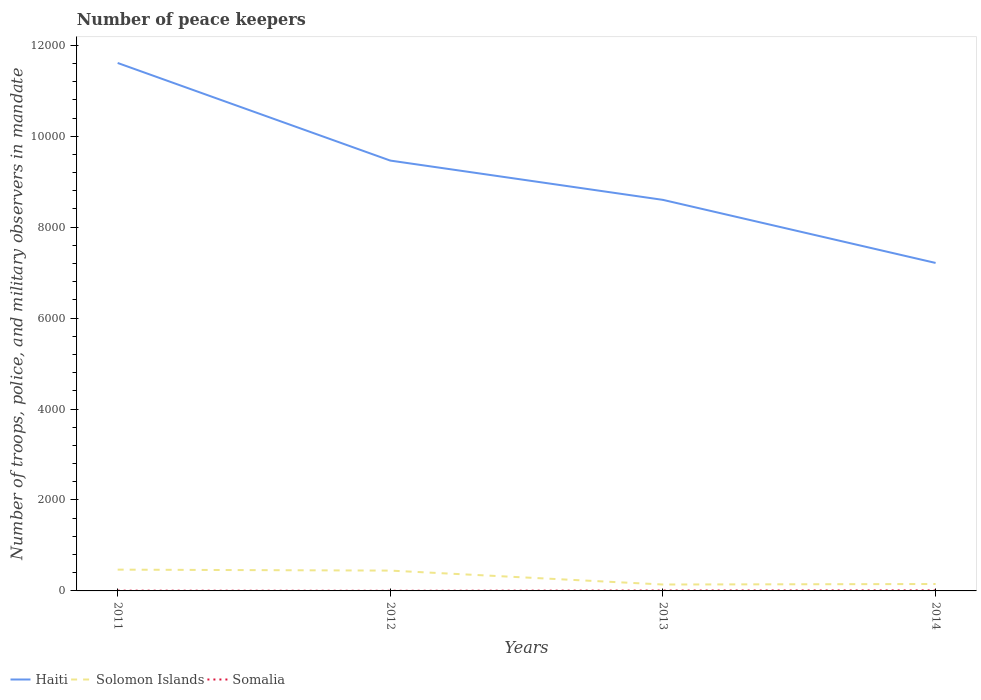Does the line corresponding to Solomon Islands intersect with the line corresponding to Haiti?
Ensure brevity in your answer.  No. Across all years, what is the maximum number of peace keepers in in Solomon Islands?
Ensure brevity in your answer.  141. What is the total number of peace keepers in in Somalia in the graph?
Provide a short and direct response. -3. What is the difference between the highest and the second highest number of peace keepers in in Somalia?
Your answer should be very brief. 9. How many years are there in the graph?
Give a very brief answer. 4. Does the graph contain grids?
Your response must be concise. No. Where does the legend appear in the graph?
Offer a terse response. Bottom left. What is the title of the graph?
Your response must be concise. Number of peace keepers. What is the label or title of the X-axis?
Offer a very short reply. Years. What is the label or title of the Y-axis?
Your answer should be very brief. Number of troops, police, and military observers in mandate. What is the Number of troops, police, and military observers in mandate in Haiti in 2011?
Your answer should be very brief. 1.16e+04. What is the Number of troops, police, and military observers in mandate in Solomon Islands in 2011?
Offer a terse response. 468. What is the Number of troops, police, and military observers in mandate of Haiti in 2012?
Provide a short and direct response. 9464. What is the Number of troops, police, and military observers in mandate of Solomon Islands in 2012?
Provide a short and direct response. 447. What is the Number of troops, police, and military observers in mandate of Somalia in 2012?
Keep it short and to the point. 3. What is the Number of troops, police, and military observers in mandate in Haiti in 2013?
Keep it short and to the point. 8600. What is the Number of troops, police, and military observers in mandate in Solomon Islands in 2013?
Your answer should be very brief. 141. What is the Number of troops, police, and military observers in mandate in Haiti in 2014?
Offer a terse response. 7213. What is the Number of troops, police, and military observers in mandate in Solomon Islands in 2014?
Offer a very short reply. 152. Across all years, what is the maximum Number of troops, police, and military observers in mandate of Haiti?
Keep it short and to the point. 1.16e+04. Across all years, what is the maximum Number of troops, police, and military observers in mandate of Solomon Islands?
Provide a short and direct response. 468. Across all years, what is the maximum Number of troops, police, and military observers in mandate of Somalia?
Ensure brevity in your answer.  12. Across all years, what is the minimum Number of troops, police, and military observers in mandate in Haiti?
Your answer should be very brief. 7213. Across all years, what is the minimum Number of troops, police, and military observers in mandate of Solomon Islands?
Your response must be concise. 141. Across all years, what is the minimum Number of troops, police, and military observers in mandate of Somalia?
Your answer should be compact. 3. What is the total Number of troops, police, and military observers in mandate of Haiti in the graph?
Your answer should be compact. 3.69e+04. What is the total Number of troops, police, and military observers in mandate in Solomon Islands in the graph?
Provide a succinct answer. 1208. What is the difference between the Number of troops, police, and military observers in mandate of Haiti in 2011 and that in 2012?
Keep it short and to the point. 2147. What is the difference between the Number of troops, police, and military observers in mandate in Somalia in 2011 and that in 2012?
Offer a very short reply. 3. What is the difference between the Number of troops, police, and military observers in mandate in Haiti in 2011 and that in 2013?
Your answer should be very brief. 3011. What is the difference between the Number of troops, police, and military observers in mandate in Solomon Islands in 2011 and that in 2013?
Offer a very short reply. 327. What is the difference between the Number of troops, police, and military observers in mandate in Haiti in 2011 and that in 2014?
Keep it short and to the point. 4398. What is the difference between the Number of troops, police, and military observers in mandate of Solomon Islands in 2011 and that in 2014?
Make the answer very short. 316. What is the difference between the Number of troops, police, and military observers in mandate of Somalia in 2011 and that in 2014?
Provide a short and direct response. -6. What is the difference between the Number of troops, police, and military observers in mandate in Haiti in 2012 and that in 2013?
Offer a terse response. 864. What is the difference between the Number of troops, police, and military observers in mandate in Solomon Islands in 2012 and that in 2013?
Make the answer very short. 306. What is the difference between the Number of troops, police, and military observers in mandate of Somalia in 2012 and that in 2013?
Make the answer very short. -6. What is the difference between the Number of troops, police, and military observers in mandate of Haiti in 2012 and that in 2014?
Your answer should be compact. 2251. What is the difference between the Number of troops, police, and military observers in mandate in Solomon Islands in 2012 and that in 2014?
Give a very brief answer. 295. What is the difference between the Number of troops, police, and military observers in mandate in Haiti in 2013 and that in 2014?
Provide a succinct answer. 1387. What is the difference between the Number of troops, police, and military observers in mandate of Somalia in 2013 and that in 2014?
Keep it short and to the point. -3. What is the difference between the Number of troops, police, and military observers in mandate of Haiti in 2011 and the Number of troops, police, and military observers in mandate of Solomon Islands in 2012?
Your answer should be compact. 1.12e+04. What is the difference between the Number of troops, police, and military observers in mandate in Haiti in 2011 and the Number of troops, police, and military observers in mandate in Somalia in 2012?
Your answer should be compact. 1.16e+04. What is the difference between the Number of troops, police, and military observers in mandate in Solomon Islands in 2011 and the Number of troops, police, and military observers in mandate in Somalia in 2012?
Offer a terse response. 465. What is the difference between the Number of troops, police, and military observers in mandate in Haiti in 2011 and the Number of troops, police, and military observers in mandate in Solomon Islands in 2013?
Your response must be concise. 1.15e+04. What is the difference between the Number of troops, police, and military observers in mandate in Haiti in 2011 and the Number of troops, police, and military observers in mandate in Somalia in 2013?
Your answer should be very brief. 1.16e+04. What is the difference between the Number of troops, police, and military observers in mandate of Solomon Islands in 2011 and the Number of troops, police, and military observers in mandate of Somalia in 2013?
Your response must be concise. 459. What is the difference between the Number of troops, police, and military observers in mandate of Haiti in 2011 and the Number of troops, police, and military observers in mandate of Solomon Islands in 2014?
Provide a short and direct response. 1.15e+04. What is the difference between the Number of troops, police, and military observers in mandate of Haiti in 2011 and the Number of troops, police, and military observers in mandate of Somalia in 2014?
Keep it short and to the point. 1.16e+04. What is the difference between the Number of troops, police, and military observers in mandate in Solomon Islands in 2011 and the Number of troops, police, and military observers in mandate in Somalia in 2014?
Your response must be concise. 456. What is the difference between the Number of troops, police, and military observers in mandate of Haiti in 2012 and the Number of troops, police, and military observers in mandate of Solomon Islands in 2013?
Provide a succinct answer. 9323. What is the difference between the Number of troops, police, and military observers in mandate of Haiti in 2012 and the Number of troops, police, and military observers in mandate of Somalia in 2013?
Keep it short and to the point. 9455. What is the difference between the Number of troops, police, and military observers in mandate in Solomon Islands in 2012 and the Number of troops, police, and military observers in mandate in Somalia in 2013?
Offer a very short reply. 438. What is the difference between the Number of troops, police, and military observers in mandate of Haiti in 2012 and the Number of troops, police, and military observers in mandate of Solomon Islands in 2014?
Provide a succinct answer. 9312. What is the difference between the Number of troops, police, and military observers in mandate in Haiti in 2012 and the Number of troops, police, and military observers in mandate in Somalia in 2014?
Your response must be concise. 9452. What is the difference between the Number of troops, police, and military observers in mandate of Solomon Islands in 2012 and the Number of troops, police, and military observers in mandate of Somalia in 2014?
Your answer should be compact. 435. What is the difference between the Number of troops, police, and military observers in mandate of Haiti in 2013 and the Number of troops, police, and military observers in mandate of Solomon Islands in 2014?
Provide a short and direct response. 8448. What is the difference between the Number of troops, police, and military observers in mandate in Haiti in 2013 and the Number of troops, police, and military observers in mandate in Somalia in 2014?
Provide a succinct answer. 8588. What is the difference between the Number of troops, police, and military observers in mandate in Solomon Islands in 2013 and the Number of troops, police, and military observers in mandate in Somalia in 2014?
Offer a very short reply. 129. What is the average Number of troops, police, and military observers in mandate of Haiti per year?
Provide a short and direct response. 9222. What is the average Number of troops, police, and military observers in mandate in Solomon Islands per year?
Ensure brevity in your answer.  302. What is the average Number of troops, police, and military observers in mandate in Somalia per year?
Offer a very short reply. 7.5. In the year 2011, what is the difference between the Number of troops, police, and military observers in mandate of Haiti and Number of troops, police, and military observers in mandate of Solomon Islands?
Make the answer very short. 1.11e+04. In the year 2011, what is the difference between the Number of troops, police, and military observers in mandate in Haiti and Number of troops, police, and military observers in mandate in Somalia?
Provide a short and direct response. 1.16e+04. In the year 2011, what is the difference between the Number of troops, police, and military observers in mandate in Solomon Islands and Number of troops, police, and military observers in mandate in Somalia?
Ensure brevity in your answer.  462. In the year 2012, what is the difference between the Number of troops, police, and military observers in mandate in Haiti and Number of troops, police, and military observers in mandate in Solomon Islands?
Ensure brevity in your answer.  9017. In the year 2012, what is the difference between the Number of troops, police, and military observers in mandate of Haiti and Number of troops, police, and military observers in mandate of Somalia?
Provide a short and direct response. 9461. In the year 2012, what is the difference between the Number of troops, police, and military observers in mandate in Solomon Islands and Number of troops, police, and military observers in mandate in Somalia?
Ensure brevity in your answer.  444. In the year 2013, what is the difference between the Number of troops, police, and military observers in mandate in Haiti and Number of troops, police, and military observers in mandate in Solomon Islands?
Ensure brevity in your answer.  8459. In the year 2013, what is the difference between the Number of troops, police, and military observers in mandate in Haiti and Number of troops, police, and military observers in mandate in Somalia?
Provide a succinct answer. 8591. In the year 2013, what is the difference between the Number of troops, police, and military observers in mandate of Solomon Islands and Number of troops, police, and military observers in mandate of Somalia?
Offer a terse response. 132. In the year 2014, what is the difference between the Number of troops, police, and military observers in mandate in Haiti and Number of troops, police, and military observers in mandate in Solomon Islands?
Offer a terse response. 7061. In the year 2014, what is the difference between the Number of troops, police, and military observers in mandate in Haiti and Number of troops, police, and military observers in mandate in Somalia?
Your response must be concise. 7201. In the year 2014, what is the difference between the Number of troops, police, and military observers in mandate in Solomon Islands and Number of troops, police, and military observers in mandate in Somalia?
Your answer should be compact. 140. What is the ratio of the Number of troops, police, and military observers in mandate in Haiti in 2011 to that in 2012?
Ensure brevity in your answer.  1.23. What is the ratio of the Number of troops, police, and military observers in mandate in Solomon Islands in 2011 to that in 2012?
Offer a very short reply. 1.05. What is the ratio of the Number of troops, police, and military observers in mandate of Somalia in 2011 to that in 2012?
Make the answer very short. 2. What is the ratio of the Number of troops, police, and military observers in mandate in Haiti in 2011 to that in 2013?
Ensure brevity in your answer.  1.35. What is the ratio of the Number of troops, police, and military observers in mandate of Solomon Islands in 2011 to that in 2013?
Your answer should be very brief. 3.32. What is the ratio of the Number of troops, police, and military observers in mandate in Somalia in 2011 to that in 2013?
Provide a succinct answer. 0.67. What is the ratio of the Number of troops, police, and military observers in mandate in Haiti in 2011 to that in 2014?
Ensure brevity in your answer.  1.61. What is the ratio of the Number of troops, police, and military observers in mandate of Solomon Islands in 2011 to that in 2014?
Provide a short and direct response. 3.08. What is the ratio of the Number of troops, police, and military observers in mandate in Haiti in 2012 to that in 2013?
Your answer should be very brief. 1.1. What is the ratio of the Number of troops, police, and military observers in mandate of Solomon Islands in 2012 to that in 2013?
Keep it short and to the point. 3.17. What is the ratio of the Number of troops, police, and military observers in mandate in Haiti in 2012 to that in 2014?
Make the answer very short. 1.31. What is the ratio of the Number of troops, police, and military observers in mandate of Solomon Islands in 2012 to that in 2014?
Ensure brevity in your answer.  2.94. What is the ratio of the Number of troops, police, and military observers in mandate of Somalia in 2012 to that in 2014?
Ensure brevity in your answer.  0.25. What is the ratio of the Number of troops, police, and military observers in mandate in Haiti in 2013 to that in 2014?
Offer a very short reply. 1.19. What is the ratio of the Number of troops, police, and military observers in mandate of Solomon Islands in 2013 to that in 2014?
Offer a very short reply. 0.93. What is the difference between the highest and the second highest Number of troops, police, and military observers in mandate in Haiti?
Your response must be concise. 2147. What is the difference between the highest and the lowest Number of troops, police, and military observers in mandate of Haiti?
Offer a very short reply. 4398. What is the difference between the highest and the lowest Number of troops, police, and military observers in mandate of Solomon Islands?
Offer a very short reply. 327. What is the difference between the highest and the lowest Number of troops, police, and military observers in mandate of Somalia?
Keep it short and to the point. 9. 